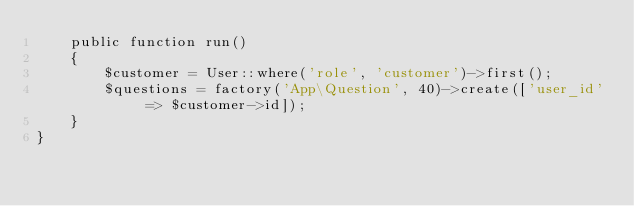<code> <loc_0><loc_0><loc_500><loc_500><_PHP_>    public function run()
    {
        $customer = User::where('role', 'customer')->first();
        $questions = factory('App\Question', 40)->create(['user_id' => $customer->id]);
    }
}
</code> 